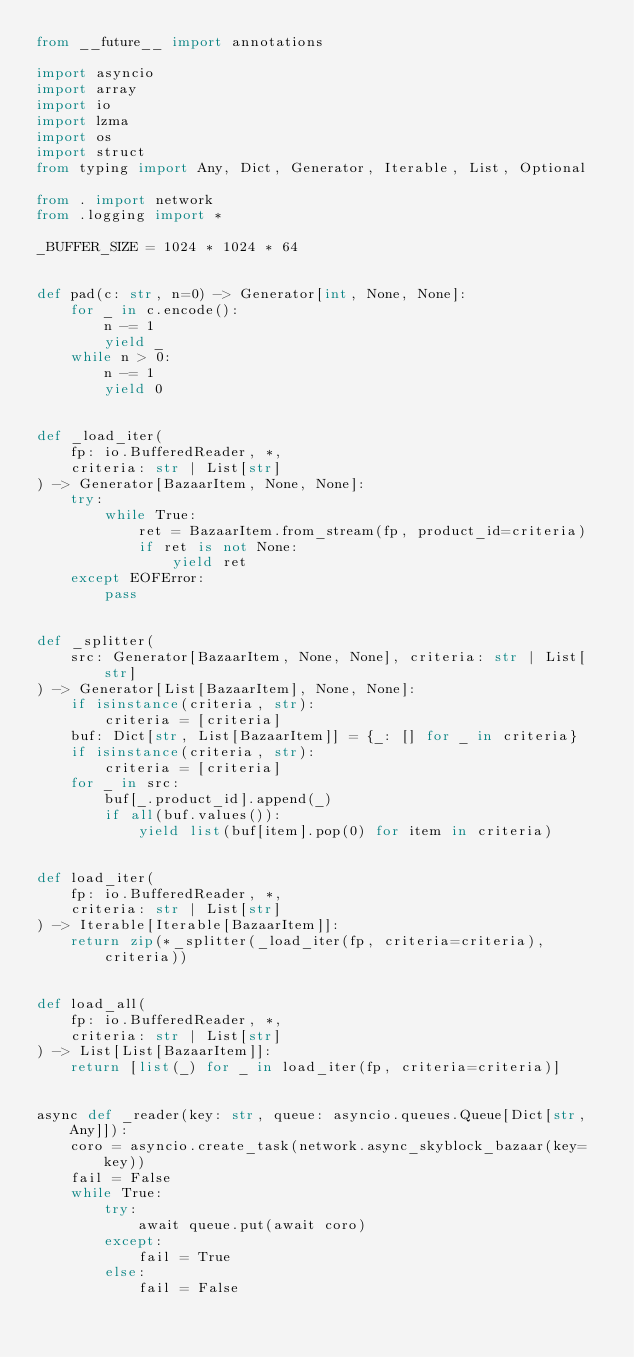<code> <loc_0><loc_0><loc_500><loc_500><_Python_>from __future__ import annotations

import asyncio
import array
import io
import lzma
import os
import struct
from typing import Any, Dict, Generator, Iterable, List, Optional

from . import network
from .logging import *

_BUFFER_SIZE = 1024 * 1024 * 64


def pad(c: str, n=0) -> Generator[int, None, None]:
    for _ in c.encode():
        n -= 1
        yield _
    while n > 0:
        n -= 1
        yield 0


def _load_iter(
    fp: io.BufferedReader, *,
    criteria: str | List[str]
) -> Generator[BazaarItem, None, None]:
    try:
        while True:
            ret = BazaarItem.from_stream(fp, product_id=criteria)
            if ret is not None:
                yield ret
    except EOFError:
        pass


def _splitter(
    src: Generator[BazaarItem, None, None], criteria: str | List[str]
) -> Generator[List[BazaarItem], None, None]:
    if isinstance(criteria, str):
        criteria = [criteria]
    buf: Dict[str, List[BazaarItem]] = {_: [] for _ in criteria}
    if isinstance(criteria, str):
        criteria = [criteria]
    for _ in src:
        buf[_.product_id].append(_)
        if all(buf.values()):
            yield list(buf[item].pop(0) for item in criteria)


def load_iter(
    fp: io.BufferedReader, *,
    criteria: str | List[str]
) -> Iterable[Iterable[BazaarItem]]:
    return zip(*_splitter(_load_iter(fp, criteria=criteria), criteria))


def load_all(
    fp: io.BufferedReader, *,
    criteria: str | List[str]
) -> List[List[BazaarItem]]:
    return [list(_) for _ in load_iter(fp, criteria=criteria)]


async def _reader(key: str, queue: asyncio.queues.Queue[Dict[str, Any]]):
    coro = asyncio.create_task(network.async_skyblock_bazaar(key=key))
    fail = False
    while True:
        try:
            await queue.put(await coro)
        except:
            fail = True
        else:
            fail = False</code> 